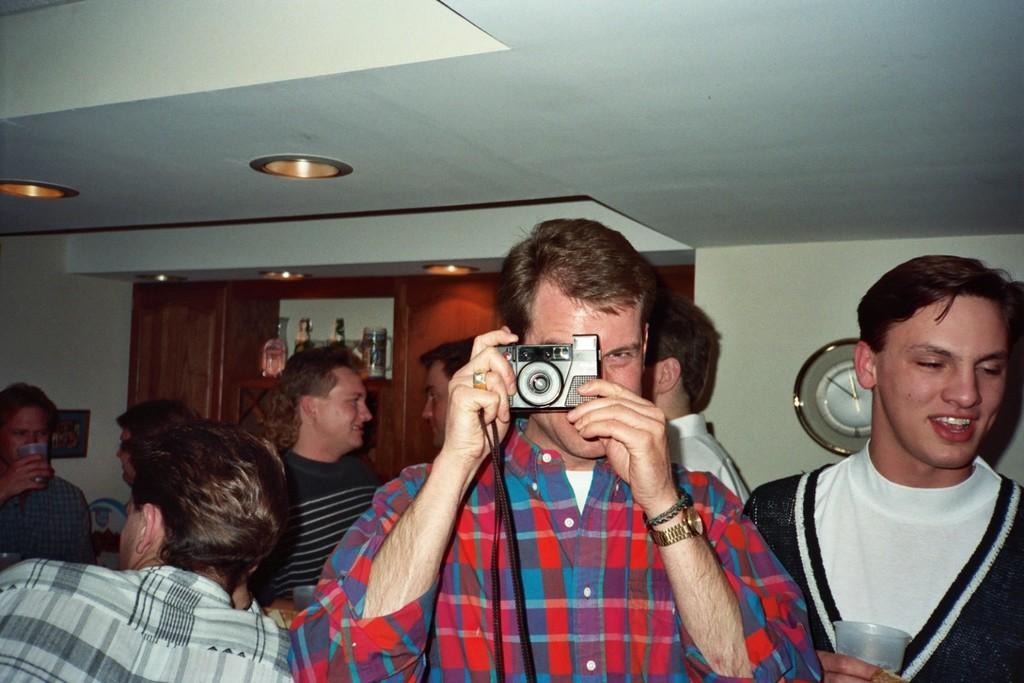Describe this image in one or two sentences. A group of men in a hall. Of them a man is taking a picture with a camera. 